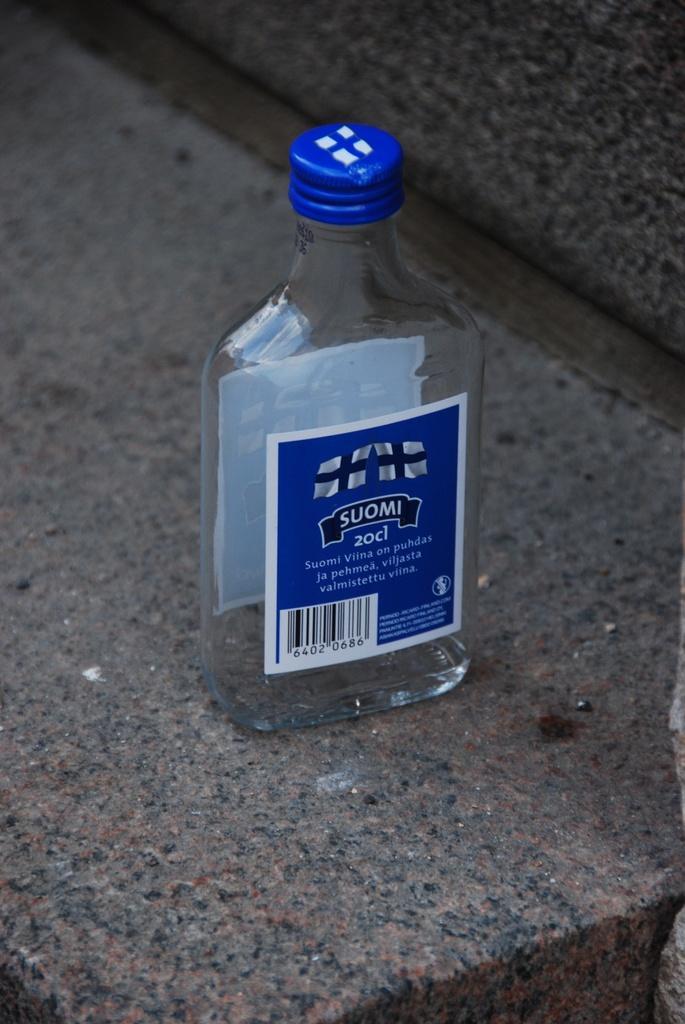Describe this image in one or two sentences. This picture shows an empty bottle 